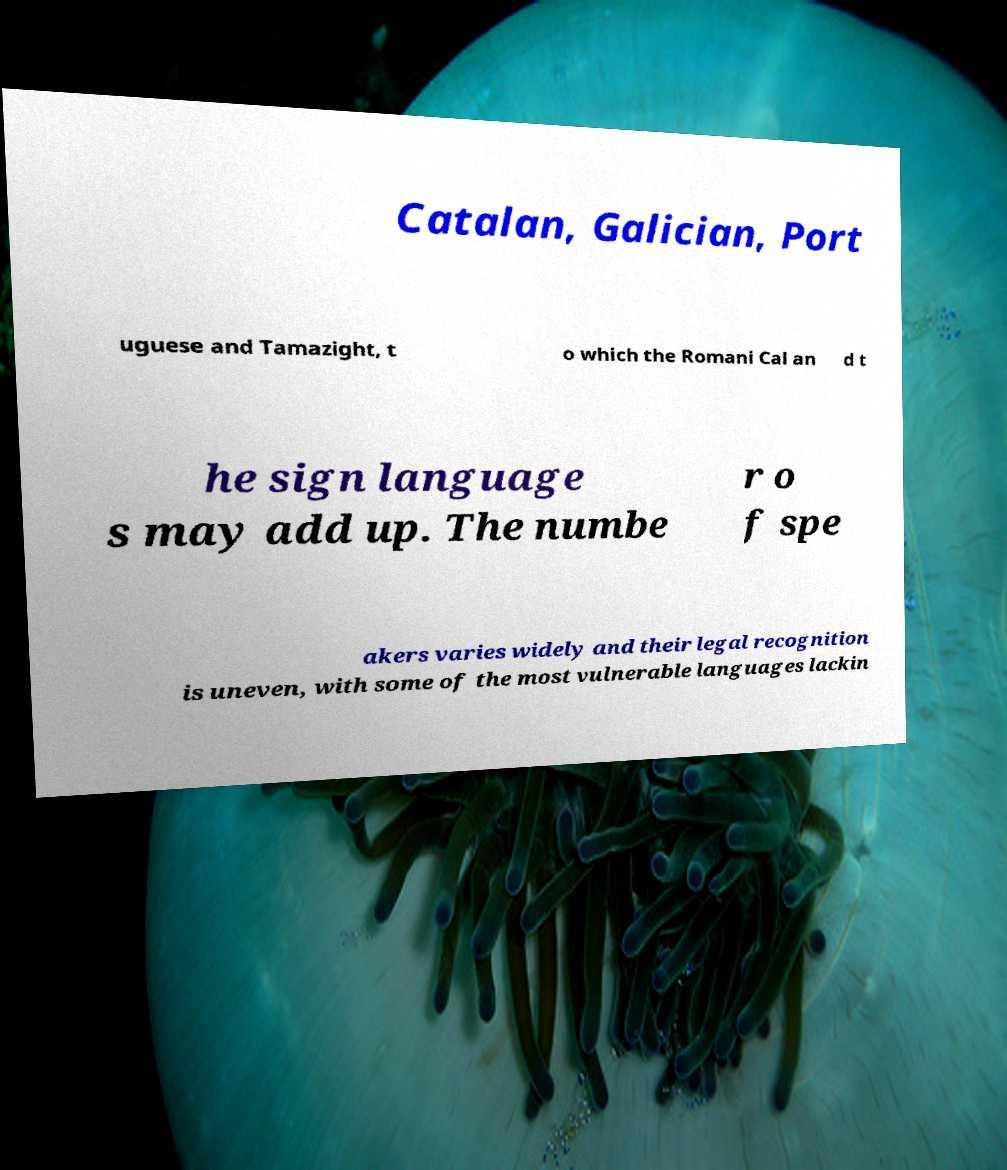Could you extract and type out the text from this image? Catalan, Galician, Port uguese and Tamazight, t o which the Romani Cal an d t he sign language s may add up. The numbe r o f spe akers varies widely and their legal recognition is uneven, with some of the most vulnerable languages lackin 